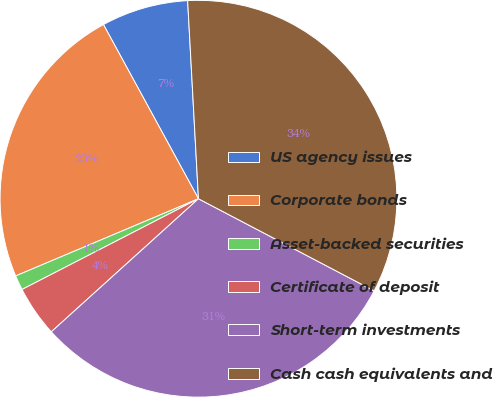Convert chart to OTSL. <chart><loc_0><loc_0><loc_500><loc_500><pie_chart><fcel>US agency issues<fcel>Corporate bonds<fcel>Asset-backed securities<fcel>Certificate of deposit<fcel>Short-term investments<fcel>Cash cash equivalents and<nl><fcel>7.08%<fcel>23.41%<fcel>1.2%<fcel>4.14%<fcel>30.61%<fcel>33.55%<nl></chart> 